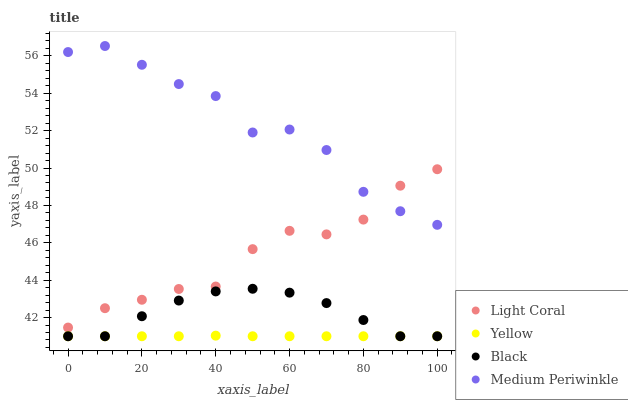Does Yellow have the minimum area under the curve?
Answer yes or no. Yes. Does Medium Periwinkle have the maximum area under the curve?
Answer yes or no. Yes. Does Black have the minimum area under the curve?
Answer yes or no. No. Does Black have the maximum area under the curve?
Answer yes or no. No. Is Yellow the smoothest?
Answer yes or no. Yes. Is Medium Periwinkle the roughest?
Answer yes or no. Yes. Is Black the smoothest?
Answer yes or no. No. Is Black the roughest?
Answer yes or no. No. Does Black have the lowest value?
Answer yes or no. Yes. Does Medium Periwinkle have the lowest value?
Answer yes or no. No. Does Medium Periwinkle have the highest value?
Answer yes or no. Yes. Does Black have the highest value?
Answer yes or no. No. Is Yellow less than Light Coral?
Answer yes or no. Yes. Is Light Coral greater than Yellow?
Answer yes or no. Yes. Does Medium Periwinkle intersect Light Coral?
Answer yes or no. Yes. Is Medium Periwinkle less than Light Coral?
Answer yes or no. No. Is Medium Periwinkle greater than Light Coral?
Answer yes or no. No. Does Yellow intersect Light Coral?
Answer yes or no. No. 